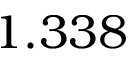Convert formula to latex. <formula><loc_0><loc_0><loc_500><loc_500>1 . 3 3 8</formula> 